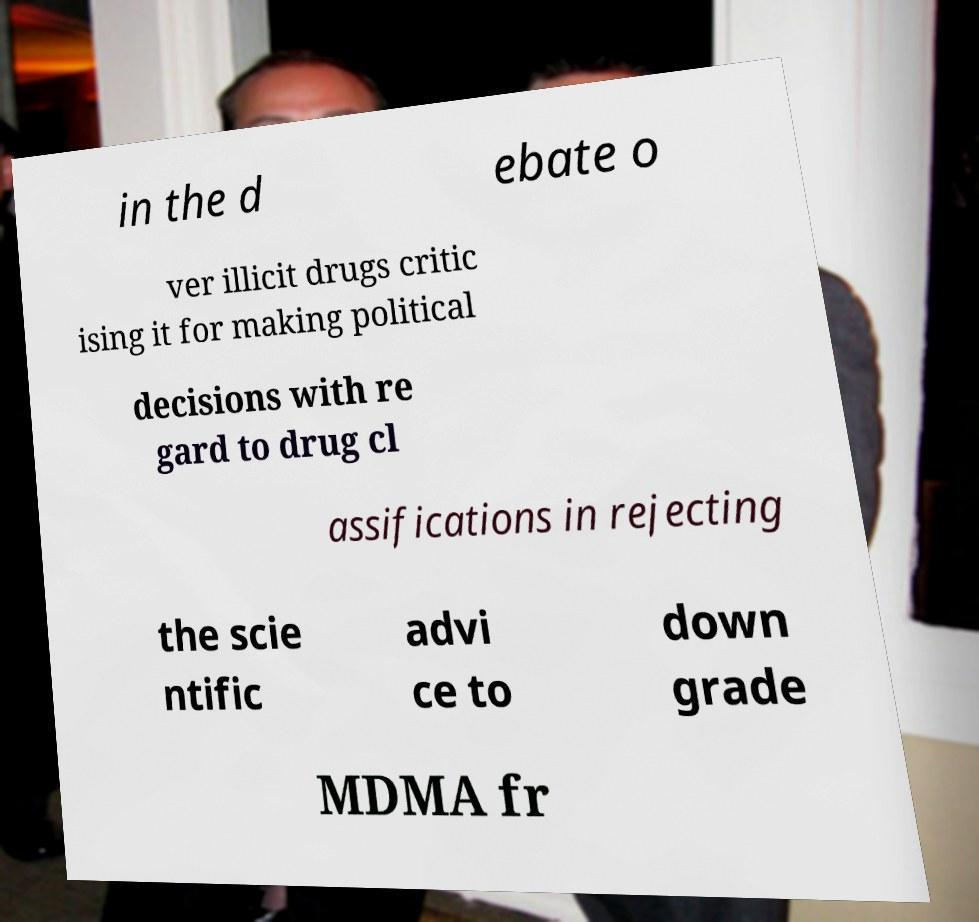Can you accurately transcribe the text from the provided image for me? in the d ebate o ver illicit drugs critic ising it for making political decisions with re gard to drug cl assifications in rejecting the scie ntific advi ce to down grade MDMA fr 